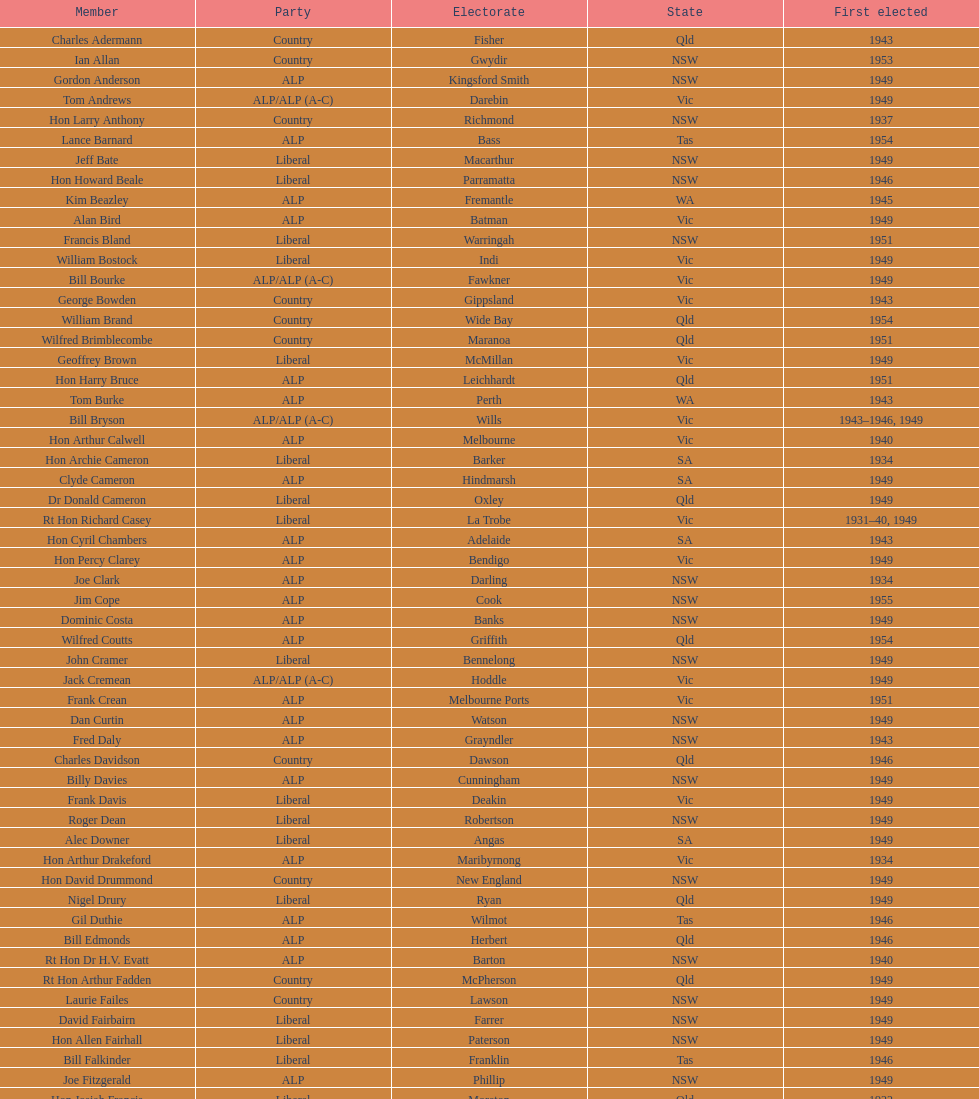After tom burke was elected, what was the next year where another tom would be elected? 1937. 